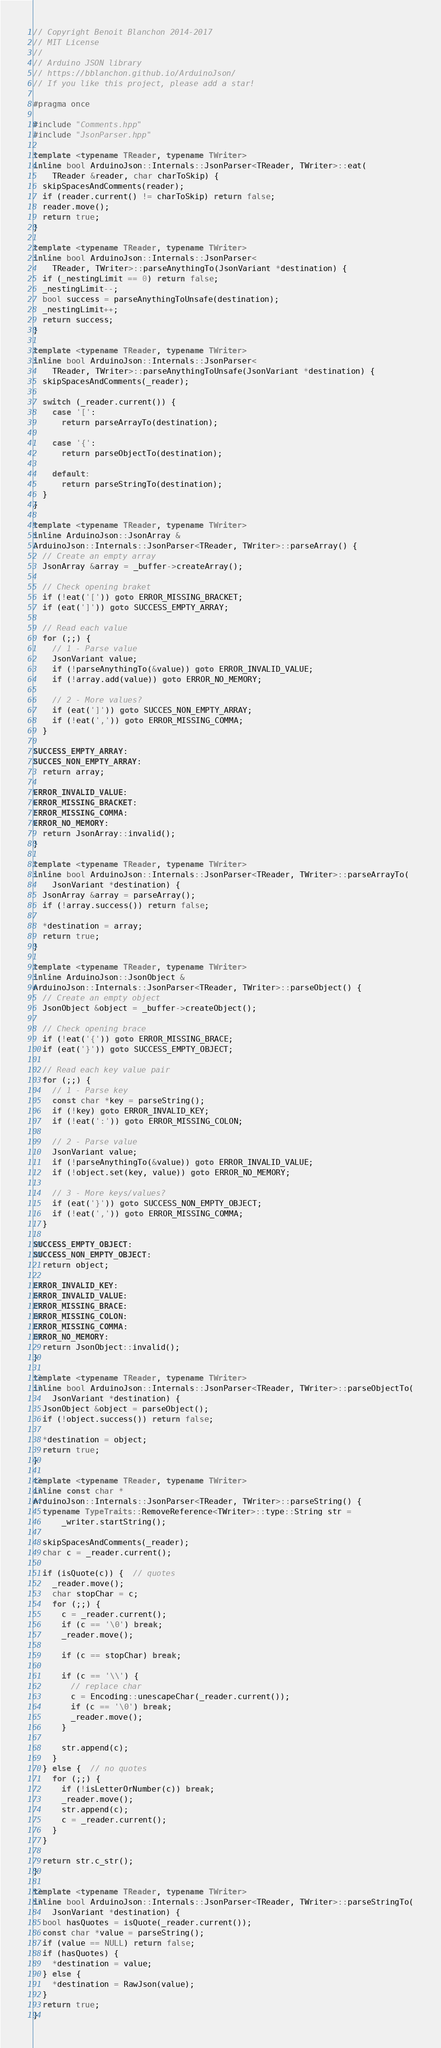Convert code to text. <code><loc_0><loc_0><loc_500><loc_500><_C++_>// Copyright Benoit Blanchon 2014-2017
// MIT License
//
// Arduino JSON library
// https://bblanchon.github.io/ArduinoJson/
// If you like this project, please add a star!

#pragma once

#include "Comments.hpp"
#include "JsonParser.hpp"

template <typename TReader, typename TWriter>
inline bool ArduinoJson::Internals::JsonParser<TReader, TWriter>::eat(
    TReader &reader, char charToSkip) {
  skipSpacesAndComments(reader);
  if (reader.current() != charToSkip) return false;
  reader.move();
  return true;
}

template <typename TReader, typename TWriter>
inline bool ArduinoJson::Internals::JsonParser<
    TReader, TWriter>::parseAnythingTo(JsonVariant *destination) {
  if (_nestingLimit == 0) return false;
  _nestingLimit--;
  bool success = parseAnythingToUnsafe(destination);
  _nestingLimit++;
  return success;
}

template <typename TReader, typename TWriter>
inline bool ArduinoJson::Internals::JsonParser<
    TReader, TWriter>::parseAnythingToUnsafe(JsonVariant *destination) {
  skipSpacesAndComments(_reader);

  switch (_reader.current()) {
    case '[':
      return parseArrayTo(destination);

    case '{':
      return parseObjectTo(destination);

    default:
      return parseStringTo(destination);
  }
}

template <typename TReader, typename TWriter>
inline ArduinoJson::JsonArray &
ArduinoJson::Internals::JsonParser<TReader, TWriter>::parseArray() {
  // Create an empty array
  JsonArray &array = _buffer->createArray();

  // Check opening braket
  if (!eat('[')) goto ERROR_MISSING_BRACKET;
  if (eat(']')) goto SUCCESS_EMPTY_ARRAY;

  // Read each value
  for (;;) {
    // 1 - Parse value
    JsonVariant value;
    if (!parseAnythingTo(&value)) goto ERROR_INVALID_VALUE;
    if (!array.add(value)) goto ERROR_NO_MEMORY;

    // 2 - More values?
    if (eat(']')) goto SUCCES_NON_EMPTY_ARRAY;
    if (!eat(',')) goto ERROR_MISSING_COMMA;
  }

SUCCESS_EMPTY_ARRAY:
SUCCES_NON_EMPTY_ARRAY:
  return array;

ERROR_INVALID_VALUE:
ERROR_MISSING_BRACKET:
ERROR_MISSING_COMMA:
ERROR_NO_MEMORY:
  return JsonArray::invalid();
}

template <typename TReader, typename TWriter>
inline bool ArduinoJson::Internals::JsonParser<TReader, TWriter>::parseArrayTo(
    JsonVariant *destination) {
  JsonArray &array = parseArray();
  if (!array.success()) return false;

  *destination = array;
  return true;
}

template <typename TReader, typename TWriter>
inline ArduinoJson::JsonObject &
ArduinoJson::Internals::JsonParser<TReader, TWriter>::parseObject() {
  // Create an empty object
  JsonObject &object = _buffer->createObject();

  // Check opening brace
  if (!eat('{')) goto ERROR_MISSING_BRACE;
  if (eat('}')) goto SUCCESS_EMPTY_OBJECT;

  // Read each key value pair
  for (;;) {
    // 1 - Parse key
    const char *key = parseString();
    if (!key) goto ERROR_INVALID_KEY;
    if (!eat(':')) goto ERROR_MISSING_COLON;

    // 2 - Parse value
    JsonVariant value;
    if (!parseAnythingTo(&value)) goto ERROR_INVALID_VALUE;
    if (!object.set(key, value)) goto ERROR_NO_MEMORY;

    // 3 - More keys/values?
    if (eat('}')) goto SUCCESS_NON_EMPTY_OBJECT;
    if (!eat(',')) goto ERROR_MISSING_COMMA;
  }

SUCCESS_EMPTY_OBJECT:
SUCCESS_NON_EMPTY_OBJECT:
  return object;

ERROR_INVALID_KEY:
ERROR_INVALID_VALUE:
ERROR_MISSING_BRACE:
ERROR_MISSING_COLON:
ERROR_MISSING_COMMA:
ERROR_NO_MEMORY:
  return JsonObject::invalid();
}

template <typename TReader, typename TWriter>
inline bool ArduinoJson::Internals::JsonParser<TReader, TWriter>::parseObjectTo(
    JsonVariant *destination) {
  JsonObject &object = parseObject();
  if (!object.success()) return false;

  *destination = object;
  return true;
}

template <typename TReader, typename TWriter>
inline const char *
ArduinoJson::Internals::JsonParser<TReader, TWriter>::parseString() {
  typename TypeTraits::RemoveReference<TWriter>::type::String str =
      _writer.startString();

  skipSpacesAndComments(_reader);
  char c = _reader.current();

  if (isQuote(c)) {  // quotes
    _reader.move();
    char stopChar = c;
    for (;;) {
      c = _reader.current();
      if (c == '\0') break;
      _reader.move();

      if (c == stopChar) break;

      if (c == '\\') {
        // replace char
        c = Encoding::unescapeChar(_reader.current());
        if (c == '\0') break;
        _reader.move();
      }

      str.append(c);
    }
  } else {  // no quotes
    for (;;) {
      if (!isLetterOrNumber(c)) break;
      _reader.move();
      str.append(c);
      c = _reader.current();
    }
  }

  return str.c_str();
}

template <typename TReader, typename TWriter>
inline bool ArduinoJson::Internals::JsonParser<TReader, TWriter>::parseStringTo(
    JsonVariant *destination) {
  bool hasQuotes = isQuote(_reader.current());
  const char *value = parseString();
  if (value == NULL) return false;
  if (hasQuotes) {
    *destination = value;
  } else {
    *destination = RawJson(value);
  }
  return true;
}
</code> 